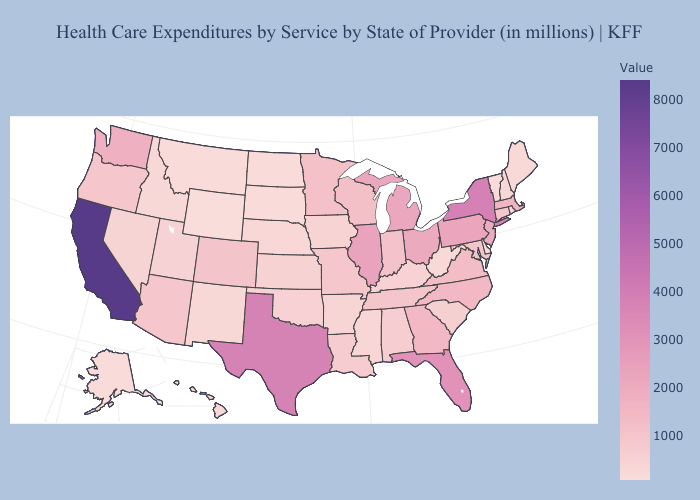Which states have the lowest value in the MidWest?
Quick response, please. North Dakota. Among the states that border Connecticut , does Rhode Island have the highest value?
Give a very brief answer. No. Which states have the lowest value in the West?
Short answer required. Wyoming. Is the legend a continuous bar?
Quick response, please. Yes. Does North Dakota have the lowest value in the MidWest?
Answer briefly. Yes. Among the states that border Florida , does Georgia have the lowest value?
Keep it brief. No. 